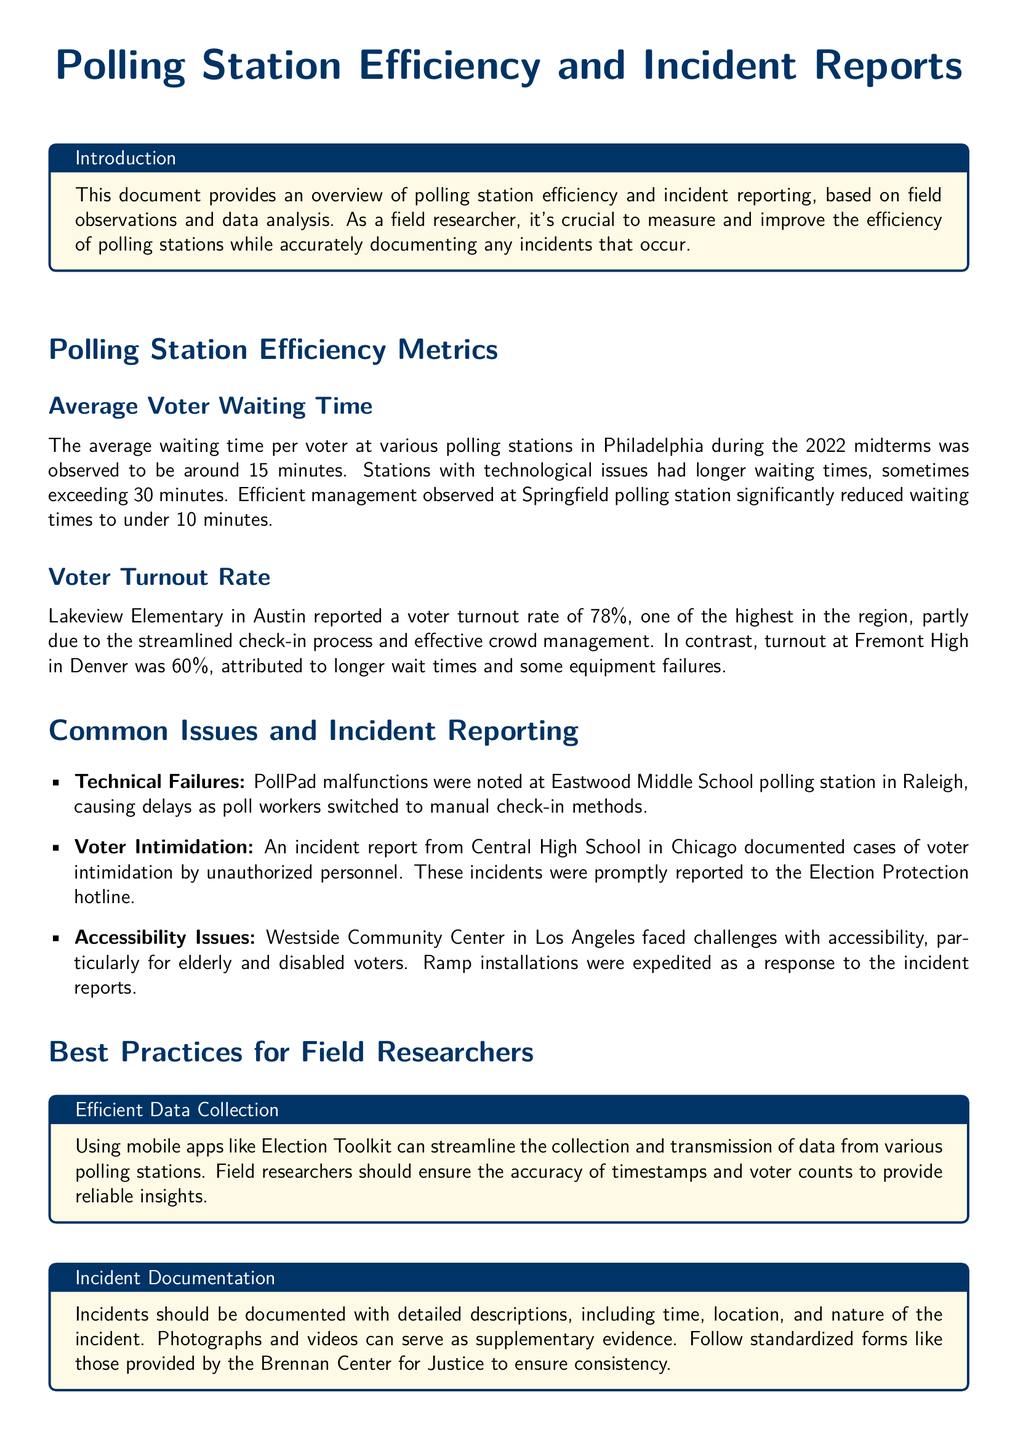What was the average voter waiting time during the 2022 midterms? The average waiting time was observed to be around 15 minutes at various polling stations in Philadelphia during the 2022 midterms.
Answer: 15 minutes What was the voter turnout rate at Lakeview Elementary? Lakeview Elementary in Austin reported a voter turnout rate of 78%, one of the highest in the region.
Answer: 78% Which polling station faced technical failures due to PollPad malfunctions? PollPad malfunctions were noted at Eastwood Middle School polling station in Raleigh, causing delays.
Answer: Eastwood Middle School What incident was documented at Central High School? An incident report from Central High School in Chicago documented cases of voter intimidation by unauthorized personnel.
Answer: Voter intimidation What is the recommended mobile app for efficient data collection? Using mobile apps like Election Toolkit can streamline the collection and transmission of data from various polling stations.
Answer: Election Toolkit Which polling station in Los Angeles faced accessibility issues? Westside Community Center in Los Angeles faced challenges with accessibility, particularly for elderly and disabled voters.
Answer: Westside Community Center What is a key element to include in incident documentation? Incidents should be documented with detailed descriptions, including time, location, and nature of the incident.
Answer: Detailed descriptions What is the role of field researchers according to the document? Field researchers play a pivotal role in collecting meaningful data and ensuring that elections run smoothly and fairly.
Answer: Collecting meaningful data 